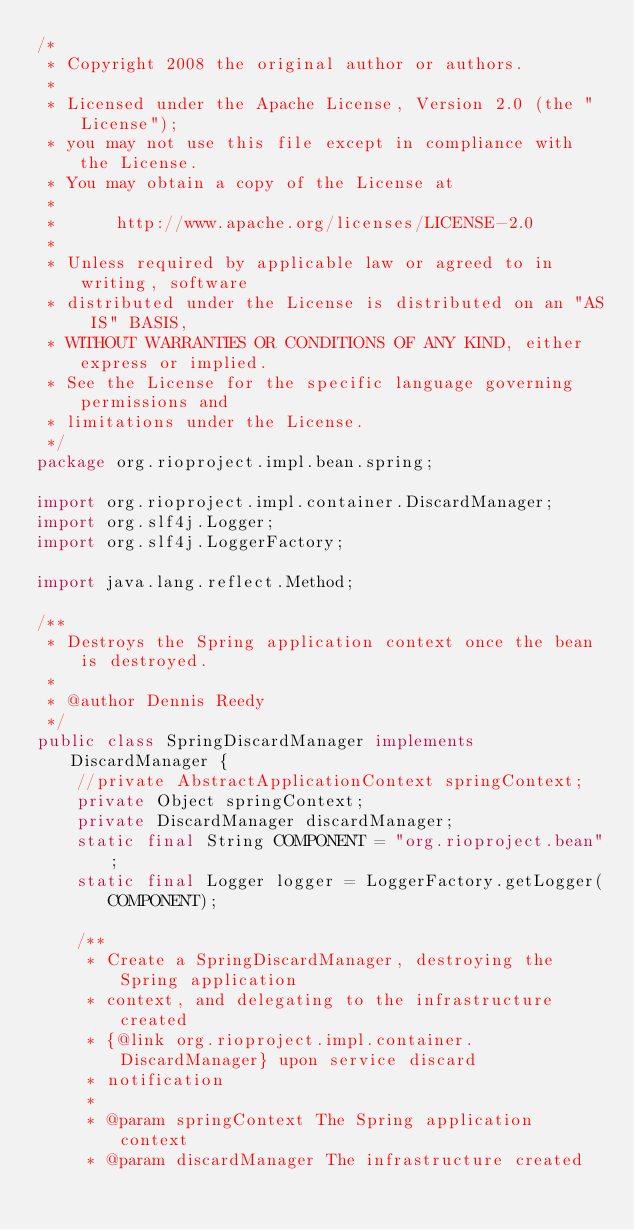Convert code to text. <code><loc_0><loc_0><loc_500><loc_500><_Java_>/*
 * Copyright 2008 the original author or authors.
 *
 * Licensed under the Apache License, Version 2.0 (the "License");
 * you may not use this file except in compliance with the License.
 * You may obtain a copy of the License at
 *
 *      http://www.apache.org/licenses/LICENSE-2.0
 *
 * Unless required by applicable law or agreed to in writing, software
 * distributed under the License is distributed on an "AS IS" BASIS,
 * WITHOUT WARRANTIES OR CONDITIONS OF ANY KIND, either express or implied.
 * See the License for the specific language governing permissions and
 * limitations under the License.
 */
package org.rioproject.impl.bean.spring;

import org.rioproject.impl.container.DiscardManager;
import org.slf4j.Logger;
import org.slf4j.LoggerFactory;

import java.lang.reflect.Method;

/**
 * Destroys the Spring application context once the bean is destroyed.
 *
 * @author Dennis Reedy
 */
public class SpringDiscardManager implements DiscardManager {
    //private AbstractApplicationContext springContext;
    private Object springContext;
    private DiscardManager discardManager;
    static final String COMPONENT = "org.rioproject.bean";
    static final Logger logger = LoggerFactory.getLogger(COMPONENT);

    /**
     * Create a SpringDiscardManager, destroying the Spring application
     * context, and delegating to the infrastructure created
     * {@link org.rioproject.impl.container.DiscardManager} upon service discard
     * notification
     *
     * @param springContext The Spring application context
     * @param discardManager The infrastructure created</code> 